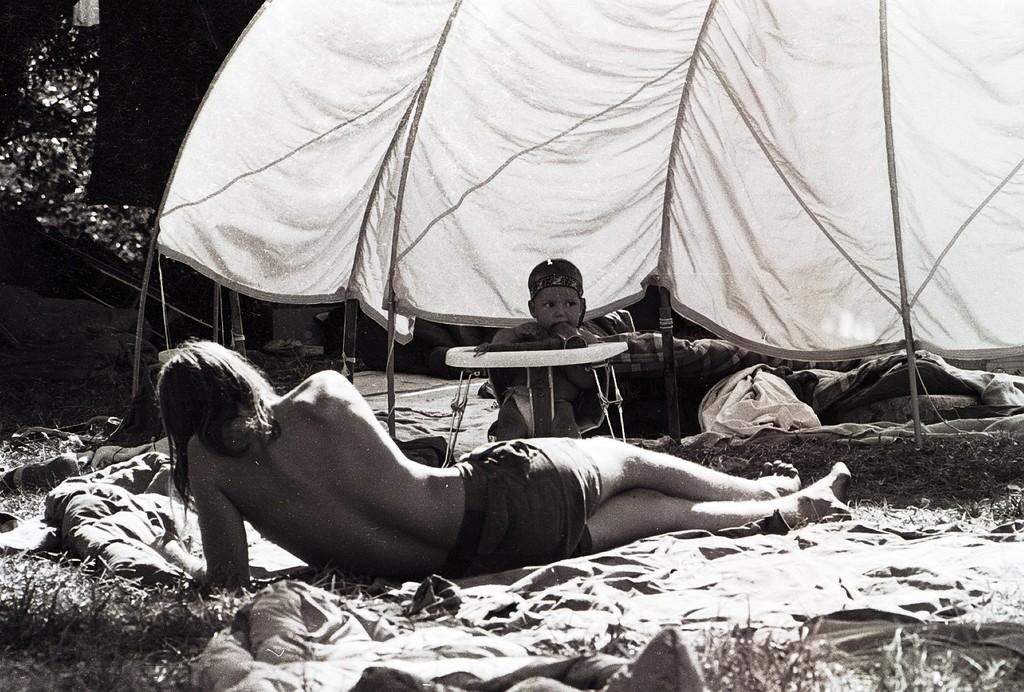What is the person in the image doing? The person is lying on the floor in the image. What structure can be seen on the right side of the image? There is a tent on the right side of the image. Can you see a stream of water flowing through the tent in the image? There is no stream of water visible in the image; it only features a person lying on the floor and a tent on the right side. Is there a marble statue inside the tent in the image? There is no marble statue present in the image. --- Facts: 1. There is a person holding a book in the image. 2. The person is sitting on a chair. 3. There is a table in front of the chair. 4. There is a lamp on the table. Absurd Topics: parrot, trampoline, volcano Conversation: What is the person in the image holding? The person is holding a book in the image. What is the person sitting on in the image? The person is sitting on a chair in the image. What object is in front of the chair in the image? There is a table in front of the chair in the image. What is on the table in the image? There is a lamp on the table in the image. Reasoning: Let's think step by step in order to produce the conversation. We start by identifying the main subject in the image, which is the person holding a book. Then, we expand the conversation to include the chair the person is sitting on, the table in front of the chair, and the lamp on the table. Each question is designed to elicit a specific detail about the image that is known from the provided facts. Absurd Question/Answer: Can you see a parrot perched on the lamp in the image? There is no parrot present in the image; it only features a person holding a book, sitting on a chair, and a table with a lamp on it. Is there a trampoline visible behind the chair in the image? There is no trampoline visible in the image. Can you see a volcano erupting in the background of the image? There is no volcano present in the image. 